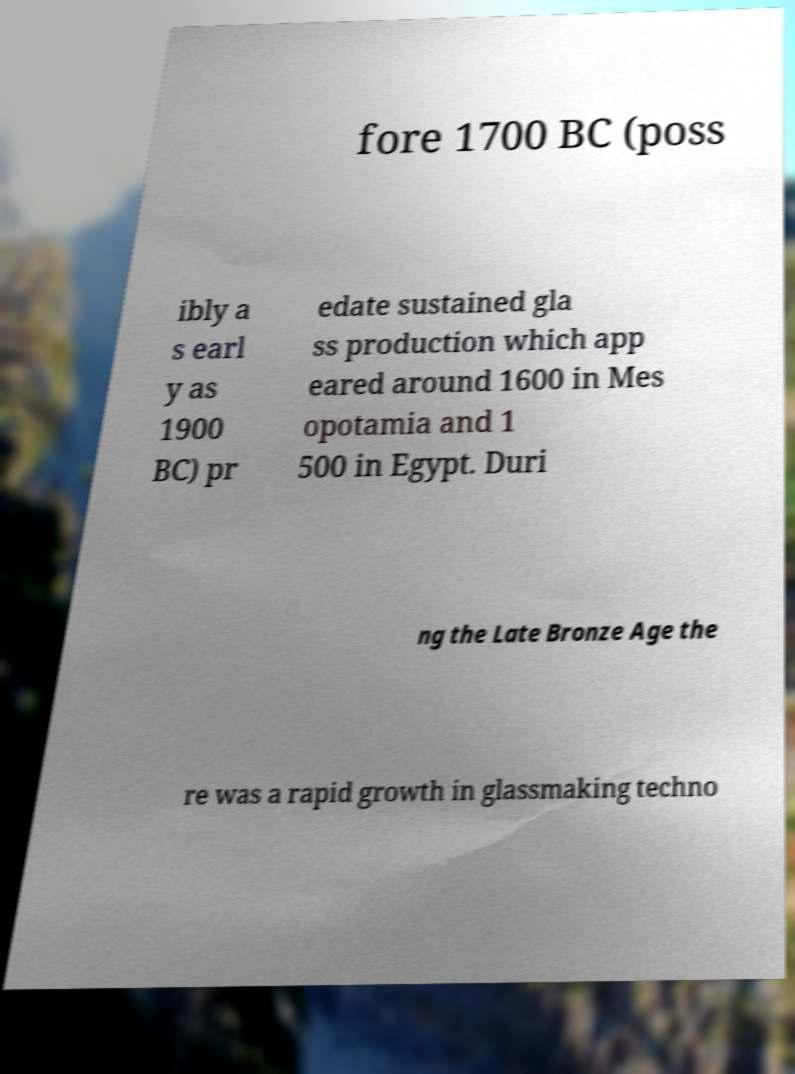Please read and relay the text visible in this image. What does it say? fore 1700 BC (poss ibly a s earl y as 1900 BC) pr edate sustained gla ss production which app eared around 1600 in Mes opotamia and 1 500 in Egypt. Duri ng the Late Bronze Age the re was a rapid growth in glassmaking techno 